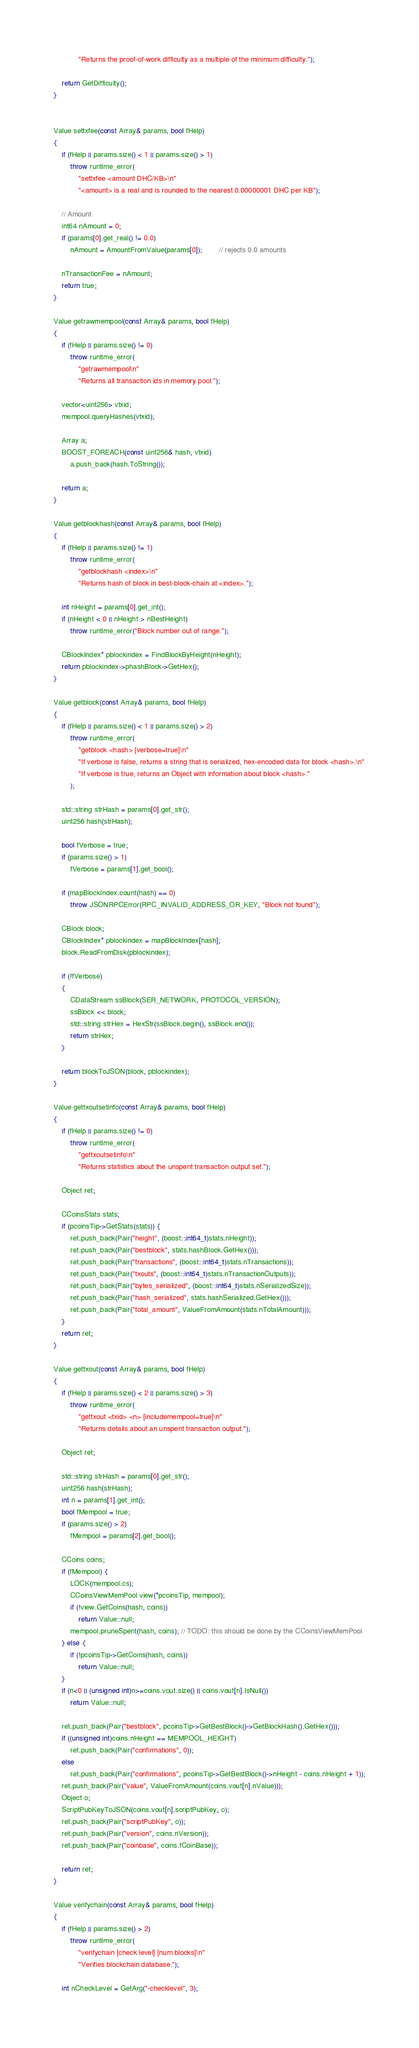<code> <loc_0><loc_0><loc_500><loc_500><_C++_>            "Returns the proof-of-work difficulty as a multiple of the minimum difficulty.");

    return GetDifficulty();
}


Value settxfee(const Array& params, bool fHelp)
{
    if (fHelp || params.size() < 1 || params.size() > 1)
        throw runtime_error(
            "settxfee <amount DHC/KB>\n"
            "<amount> is a real and is rounded to the nearest 0.00000001 DHC per KB");

    // Amount
    int64 nAmount = 0;
    if (params[0].get_real() != 0.0)
        nAmount = AmountFromValue(params[0]);        // rejects 0.0 amounts

    nTransactionFee = nAmount;
    return true;
}

Value getrawmempool(const Array& params, bool fHelp)
{
    if (fHelp || params.size() != 0)
        throw runtime_error(
            "getrawmempool\n"
            "Returns all transaction ids in memory pool.");

    vector<uint256> vtxid;
    mempool.queryHashes(vtxid);

    Array a;
    BOOST_FOREACH(const uint256& hash, vtxid)
        a.push_back(hash.ToString());

    return a;
}

Value getblockhash(const Array& params, bool fHelp)
{
    if (fHelp || params.size() != 1)
        throw runtime_error(
            "getblockhash <index>\n"
            "Returns hash of block in best-block-chain at <index>.");

    int nHeight = params[0].get_int();
    if (nHeight < 0 || nHeight > nBestHeight)
        throw runtime_error("Block number out of range.");

    CBlockIndex* pblockindex = FindBlockByHeight(nHeight);
    return pblockindex->phashBlock->GetHex();
}

Value getblock(const Array& params, bool fHelp)
{
    if (fHelp || params.size() < 1 || params.size() > 2)
        throw runtime_error(
            "getblock <hash> [verbose=true]\n"
            "If verbose is false, returns a string that is serialized, hex-encoded data for block <hash>.\n"
            "If verbose is true, returns an Object with information about block <hash>."
        );

    std::string strHash = params[0].get_str();
    uint256 hash(strHash);

    bool fVerbose = true;
    if (params.size() > 1)
        fVerbose = params[1].get_bool();

    if (mapBlockIndex.count(hash) == 0)
        throw JSONRPCError(RPC_INVALID_ADDRESS_OR_KEY, "Block not found");

    CBlock block;
    CBlockIndex* pblockindex = mapBlockIndex[hash];
    block.ReadFromDisk(pblockindex);

    if (!fVerbose)
    {
        CDataStream ssBlock(SER_NETWORK, PROTOCOL_VERSION);
        ssBlock << block;
        std::string strHex = HexStr(ssBlock.begin(), ssBlock.end());
        return strHex;
    }

    return blockToJSON(block, pblockindex);
}

Value gettxoutsetinfo(const Array& params, bool fHelp)
{
    if (fHelp || params.size() != 0)
        throw runtime_error(
            "gettxoutsetinfo\n"
            "Returns statistics about the unspent transaction output set.");

    Object ret;

    CCoinsStats stats;
    if (pcoinsTip->GetStats(stats)) {
        ret.push_back(Pair("height", (boost::int64_t)stats.nHeight));
        ret.push_back(Pair("bestblock", stats.hashBlock.GetHex()));
        ret.push_back(Pair("transactions", (boost::int64_t)stats.nTransactions));
        ret.push_back(Pair("txouts", (boost::int64_t)stats.nTransactionOutputs));
        ret.push_back(Pair("bytes_serialized", (boost::int64_t)stats.nSerializedSize));
        ret.push_back(Pair("hash_serialized", stats.hashSerialized.GetHex()));
        ret.push_back(Pair("total_amount", ValueFromAmount(stats.nTotalAmount)));
    }
    return ret;
}

Value gettxout(const Array& params, bool fHelp)
{
    if (fHelp || params.size() < 2 || params.size() > 3)
        throw runtime_error(
            "gettxout <txid> <n> [includemempool=true]\n"
            "Returns details about an unspent transaction output.");

    Object ret;

    std::string strHash = params[0].get_str();
    uint256 hash(strHash);
    int n = params[1].get_int();
    bool fMempool = true;
    if (params.size() > 2)
        fMempool = params[2].get_bool();

    CCoins coins;
    if (fMempool) {
        LOCK(mempool.cs);
        CCoinsViewMemPool view(*pcoinsTip, mempool);
        if (!view.GetCoins(hash, coins))
            return Value::null;
        mempool.pruneSpent(hash, coins); // TODO: this should be done by the CCoinsViewMemPool
    } else {
        if (!pcoinsTip->GetCoins(hash, coins))
            return Value::null;
    }
    if (n<0 || (unsigned int)n>=coins.vout.size() || coins.vout[n].IsNull())
        return Value::null;

    ret.push_back(Pair("bestblock", pcoinsTip->GetBestBlock()->GetBlockHash().GetHex()));
    if ((unsigned int)coins.nHeight == MEMPOOL_HEIGHT)
        ret.push_back(Pair("confirmations", 0));
    else
        ret.push_back(Pair("confirmations", pcoinsTip->GetBestBlock()->nHeight - coins.nHeight + 1));
    ret.push_back(Pair("value", ValueFromAmount(coins.vout[n].nValue)));
    Object o;
    ScriptPubKeyToJSON(coins.vout[n].scriptPubKey, o);
    ret.push_back(Pair("scriptPubKey", o));
    ret.push_back(Pair("version", coins.nVersion));
    ret.push_back(Pair("coinbase", coins.fCoinBase));

    return ret;
}

Value verifychain(const Array& params, bool fHelp)
{
    if (fHelp || params.size() > 2)
        throw runtime_error(
            "verifychain [check level] [num blocks]\n"
            "Verifies blockchain database.");

    int nCheckLevel = GetArg("-checklevel", 3);</code> 